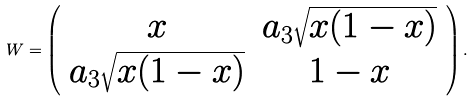<formula> <loc_0><loc_0><loc_500><loc_500>W = \left ( \begin{array} { c c } x & a _ { 3 } \sqrt { x ( 1 - x ) } \\ a _ { 3 } \sqrt { x ( 1 - x ) } & { 1 - x } \end{array} \right ) .</formula> 